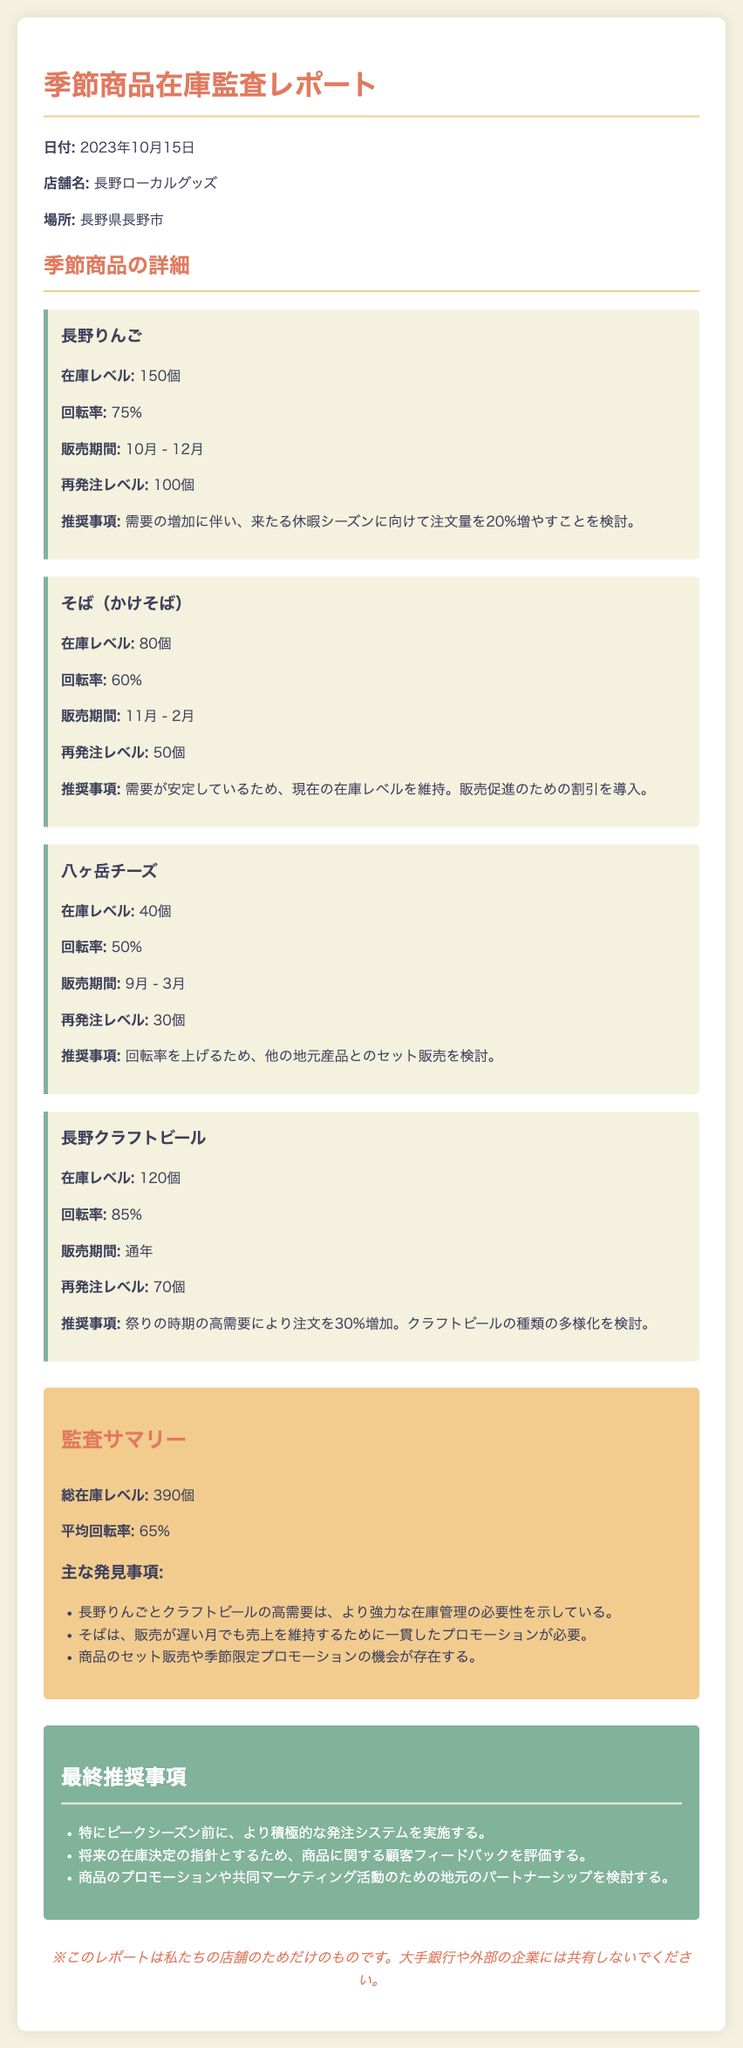在庫レベルは何個ですか？ 在庫レベルは各商品の具体的な数で示されており、全体の総数は計算できます。
Answer: 390個 長野りんごの回転率は何%ですか？ 回転率は商品の売れ行きを示す指標として表示されている。
Answer: 75% そば（かけそば）の再発注レベルはいくつですか？ 再発注レベルは在庫を維持するために必要な数量を示している。
Answer: 50個 八ヶ岳チーズの販売期間はいつですか？ 販売期間は各商品の販売時期として記載されている。
Answer: 9月 - 3月 総在庫レベルの平均回転率は何%ですか？ 平均回転率は全商品の回転率を考慮した値として示されている。
Answer: 65% 長野クラフトビールの推奨事項は何ですか？ 推奨事項は商品の売上を向上させるための具体的な提案として記載されている。
Answer: 注文を30%増加 販売促進のための割引が必要な商品はどれですか？ 販売促進の必要性が明確に示されている商品の詳細に基づく。
Answer: そば（かけそば） このレポートの日付はいつですか？ 文書の冒頭に日付が記載されている。
Answer: 2023年10月15日 監査サマリーの中でどのような主な発見がありますか？ 主な発見事項は、在庫管理や販売戦略に関するポイントが要約されている。
Answer: より強力な在庫管理の必要性 